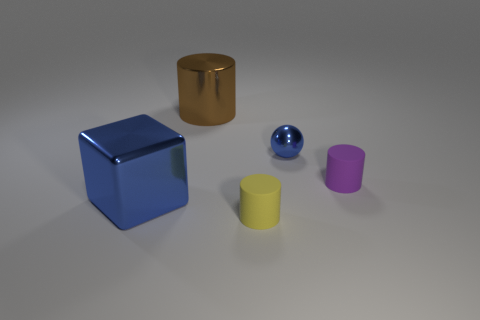Can you tell me what objects are depicted in the image and their colors? Certainly! The image displays five objects: a large blue cube, a large brown cylinder, a small blue sphere, a small yellow cylinder, and a small purple cylinder.  How are the objects arranged in relation to each other? From the perspective of the image, the objects are spaced apart on a flat surface. The blue cube is to the left, followed by the brown cylinder in the middle, and the small blue sphere is between them but slightly forward. The small yellow and purple cylinders are to the right, with the purple one being the furthest to the right and slightly behind the yellow one. 